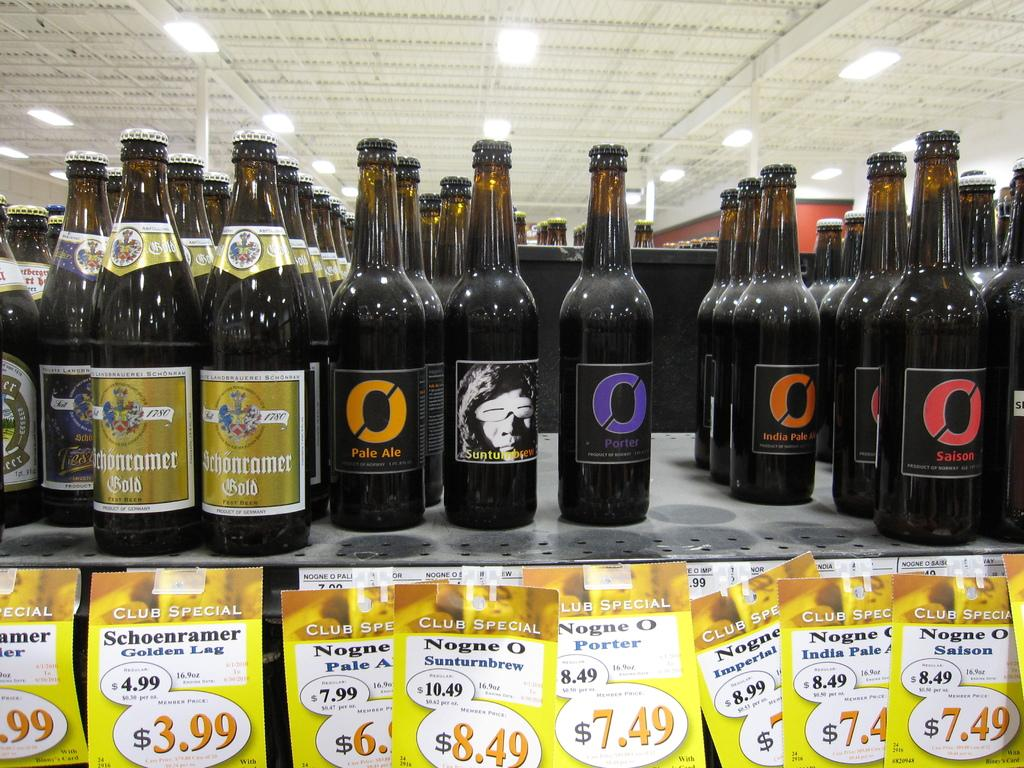<image>
Render a clear and concise summary of the photo. A wine bottle called Porter sits with other bottles. 